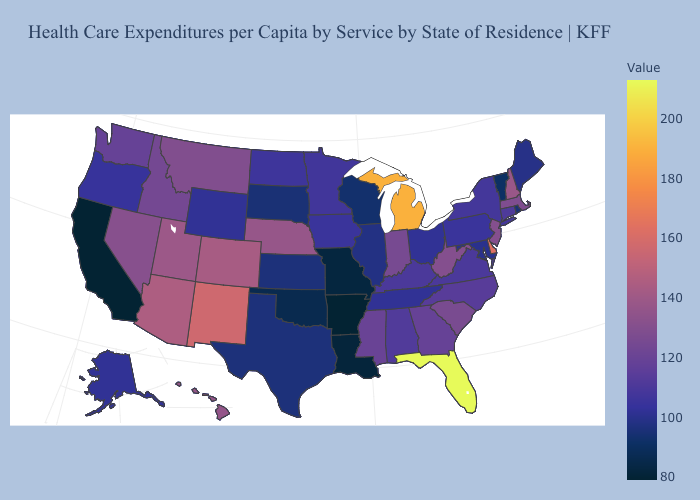Which states hav the highest value in the Northeast?
Concise answer only. New Hampshire. Does Arkansas have the highest value in the USA?
Write a very short answer. No. Among the states that border North Dakota , which have the highest value?
Give a very brief answer. Montana. Among the states that border Minnesota , does South Dakota have the highest value?
Concise answer only. No. Among the states that border New York , which have the highest value?
Give a very brief answer. New Jersey. Among the states that border New Mexico , does Arizona have the highest value?
Answer briefly. Yes. 